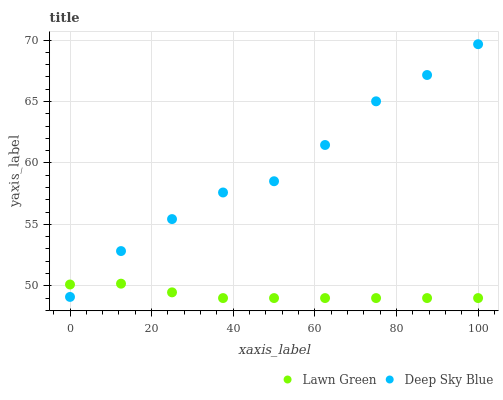Does Lawn Green have the minimum area under the curve?
Answer yes or no. Yes. Does Deep Sky Blue have the maximum area under the curve?
Answer yes or no. Yes. Does Deep Sky Blue have the minimum area under the curve?
Answer yes or no. No. Is Lawn Green the smoothest?
Answer yes or no. Yes. Is Deep Sky Blue the roughest?
Answer yes or no. Yes. Is Deep Sky Blue the smoothest?
Answer yes or no. No. Does Lawn Green have the lowest value?
Answer yes or no. Yes. Does Deep Sky Blue have the lowest value?
Answer yes or no. No. Does Deep Sky Blue have the highest value?
Answer yes or no. Yes. Does Deep Sky Blue intersect Lawn Green?
Answer yes or no. Yes. Is Deep Sky Blue less than Lawn Green?
Answer yes or no. No. Is Deep Sky Blue greater than Lawn Green?
Answer yes or no. No. 